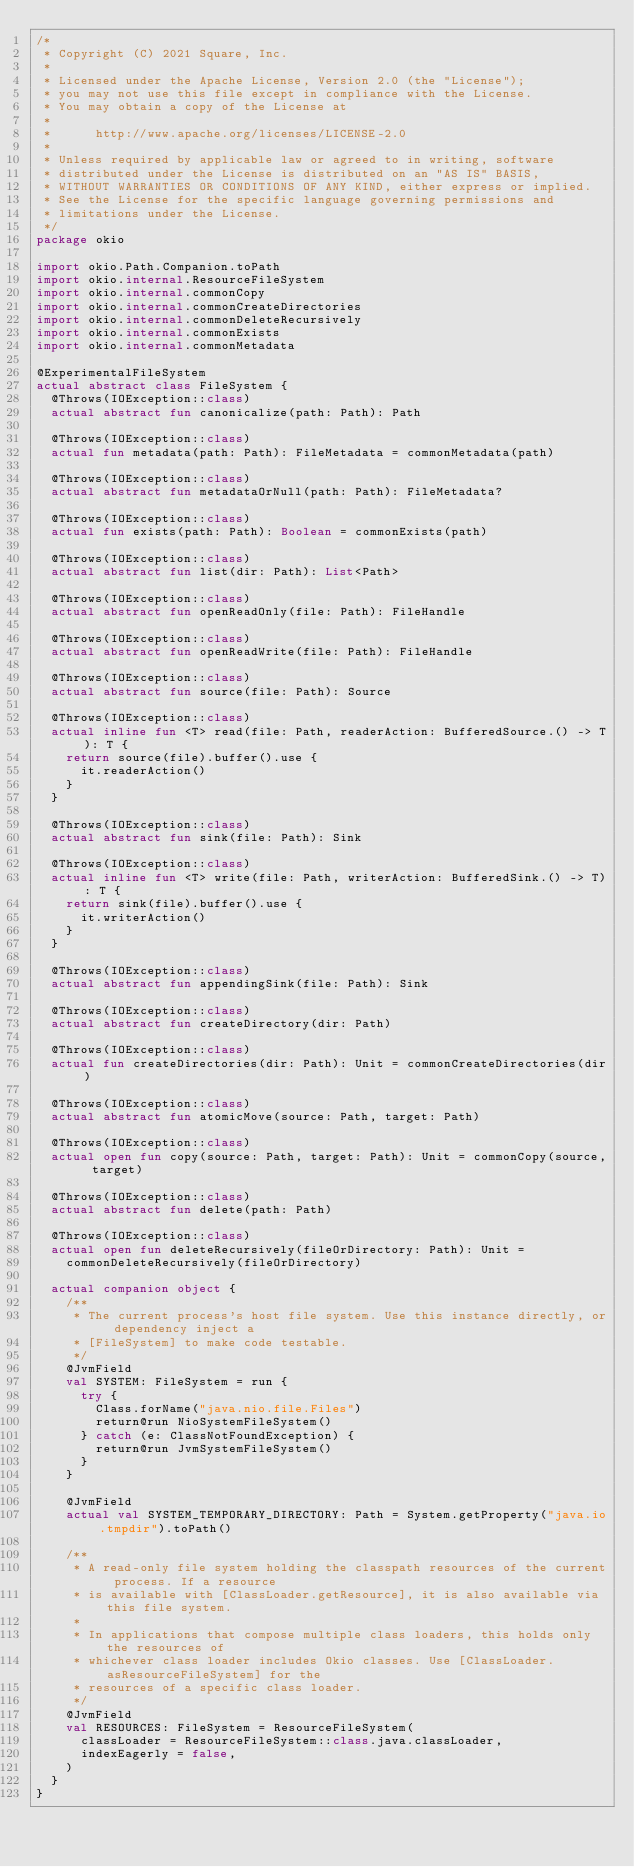<code> <loc_0><loc_0><loc_500><loc_500><_Kotlin_>/*
 * Copyright (C) 2021 Square, Inc.
 *
 * Licensed under the Apache License, Version 2.0 (the "License");
 * you may not use this file except in compliance with the License.
 * You may obtain a copy of the License at
 *
 *      http://www.apache.org/licenses/LICENSE-2.0
 *
 * Unless required by applicable law or agreed to in writing, software
 * distributed under the License is distributed on an "AS IS" BASIS,
 * WITHOUT WARRANTIES OR CONDITIONS OF ANY KIND, either express or implied.
 * See the License for the specific language governing permissions and
 * limitations under the License.
 */
package okio

import okio.Path.Companion.toPath
import okio.internal.ResourceFileSystem
import okio.internal.commonCopy
import okio.internal.commonCreateDirectories
import okio.internal.commonDeleteRecursively
import okio.internal.commonExists
import okio.internal.commonMetadata

@ExperimentalFileSystem
actual abstract class FileSystem {
  @Throws(IOException::class)
  actual abstract fun canonicalize(path: Path): Path

  @Throws(IOException::class)
  actual fun metadata(path: Path): FileMetadata = commonMetadata(path)

  @Throws(IOException::class)
  actual abstract fun metadataOrNull(path: Path): FileMetadata?

  @Throws(IOException::class)
  actual fun exists(path: Path): Boolean = commonExists(path)

  @Throws(IOException::class)
  actual abstract fun list(dir: Path): List<Path>

  @Throws(IOException::class)
  actual abstract fun openReadOnly(file: Path): FileHandle

  @Throws(IOException::class)
  actual abstract fun openReadWrite(file: Path): FileHandle

  @Throws(IOException::class)
  actual abstract fun source(file: Path): Source

  @Throws(IOException::class)
  actual inline fun <T> read(file: Path, readerAction: BufferedSource.() -> T): T {
    return source(file).buffer().use {
      it.readerAction()
    }
  }

  @Throws(IOException::class)
  actual abstract fun sink(file: Path): Sink

  @Throws(IOException::class)
  actual inline fun <T> write(file: Path, writerAction: BufferedSink.() -> T): T {
    return sink(file).buffer().use {
      it.writerAction()
    }
  }

  @Throws(IOException::class)
  actual abstract fun appendingSink(file: Path): Sink

  @Throws(IOException::class)
  actual abstract fun createDirectory(dir: Path)

  @Throws(IOException::class)
  actual fun createDirectories(dir: Path): Unit = commonCreateDirectories(dir)

  @Throws(IOException::class)
  actual abstract fun atomicMove(source: Path, target: Path)

  @Throws(IOException::class)
  actual open fun copy(source: Path, target: Path): Unit = commonCopy(source, target)

  @Throws(IOException::class)
  actual abstract fun delete(path: Path)

  @Throws(IOException::class)
  actual open fun deleteRecursively(fileOrDirectory: Path): Unit =
    commonDeleteRecursively(fileOrDirectory)

  actual companion object {
    /**
     * The current process's host file system. Use this instance directly, or dependency inject a
     * [FileSystem] to make code testable.
     */
    @JvmField
    val SYSTEM: FileSystem = run {
      try {
        Class.forName("java.nio.file.Files")
        return@run NioSystemFileSystem()
      } catch (e: ClassNotFoundException) {
        return@run JvmSystemFileSystem()
      }
    }

    @JvmField
    actual val SYSTEM_TEMPORARY_DIRECTORY: Path = System.getProperty("java.io.tmpdir").toPath()

    /**
     * A read-only file system holding the classpath resources of the current process. If a resource
     * is available with [ClassLoader.getResource], it is also available via this file system.
     *
     * In applications that compose multiple class loaders, this holds only the resources of
     * whichever class loader includes Okio classes. Use [ClassLoader.asResourceFileSystem] for the
     * resources of a specific class loader.
     */
    @JvmField
    val RESOURCES: FileSystem = ResourceFileSystem(
      classLoader = ResourceFileSystem::class.java.classLoader,
      indexEagerly = false,
    )
  }
}
</code> 